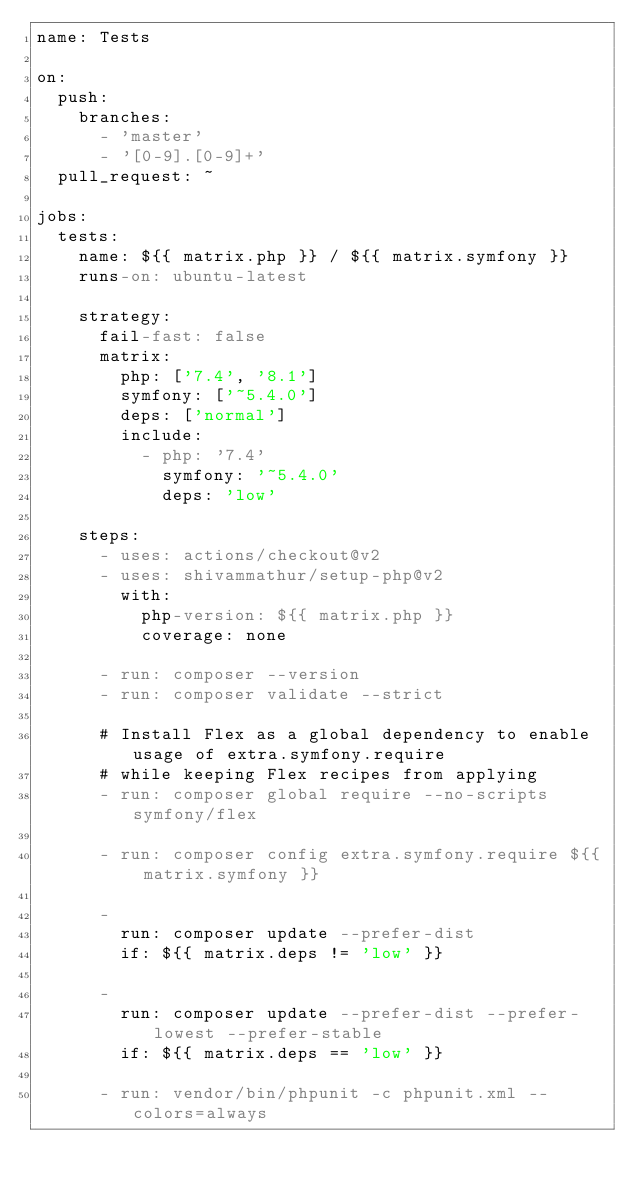Convert code to text. <code><loc_0><loc_0><loc_500><loc_500><_YAML_>name: Tests

on:
  push:
    branches:
      - 'master'
      - '[0-9].[0-9]+'
  pull_request: ~

jobs:
  tests:
    name: ${{ matrix.php }} / ${{ matrix.symfony }}
    runs-on: ubuntu-latest

    strategy:
      fail-fast: false
      matrix:
        php: ['7.4', '8.1']
        symfony: ['~5.4.0']
        deps: ['normal']
        include:
          - php: '7.4'
            symfony: '~5.4.0'
            deps: 'low'

    steps:
      - uses: actions/checkout@v2
      - uses: shivammathur/setup-php@v2
        with:
          php-version: ${{ matrix.php }}
          coverage: none

      - run: composer --version
      - run: composer validate --strict

      # Install Flex as a global dependency to enable usage of extra.symfony.require
      # while keeping Flex recipes from applying
      - run: composer global require --no-scripts symfony/flex

      - run: composer config extra.symfony.require ${{ matrix.symfony }}

      -
        run: composer update --prefer-dist
        if: ${{ matrix.deps != 'low' }}

      -
        run: composer update --prefer-dist --prefer-lowest --prefer-stable
        if: ${{ matrix.deps == 'low' }}

      - run: vendor/bin/phpunit -c phpunit.xml --colors=always
</code> 